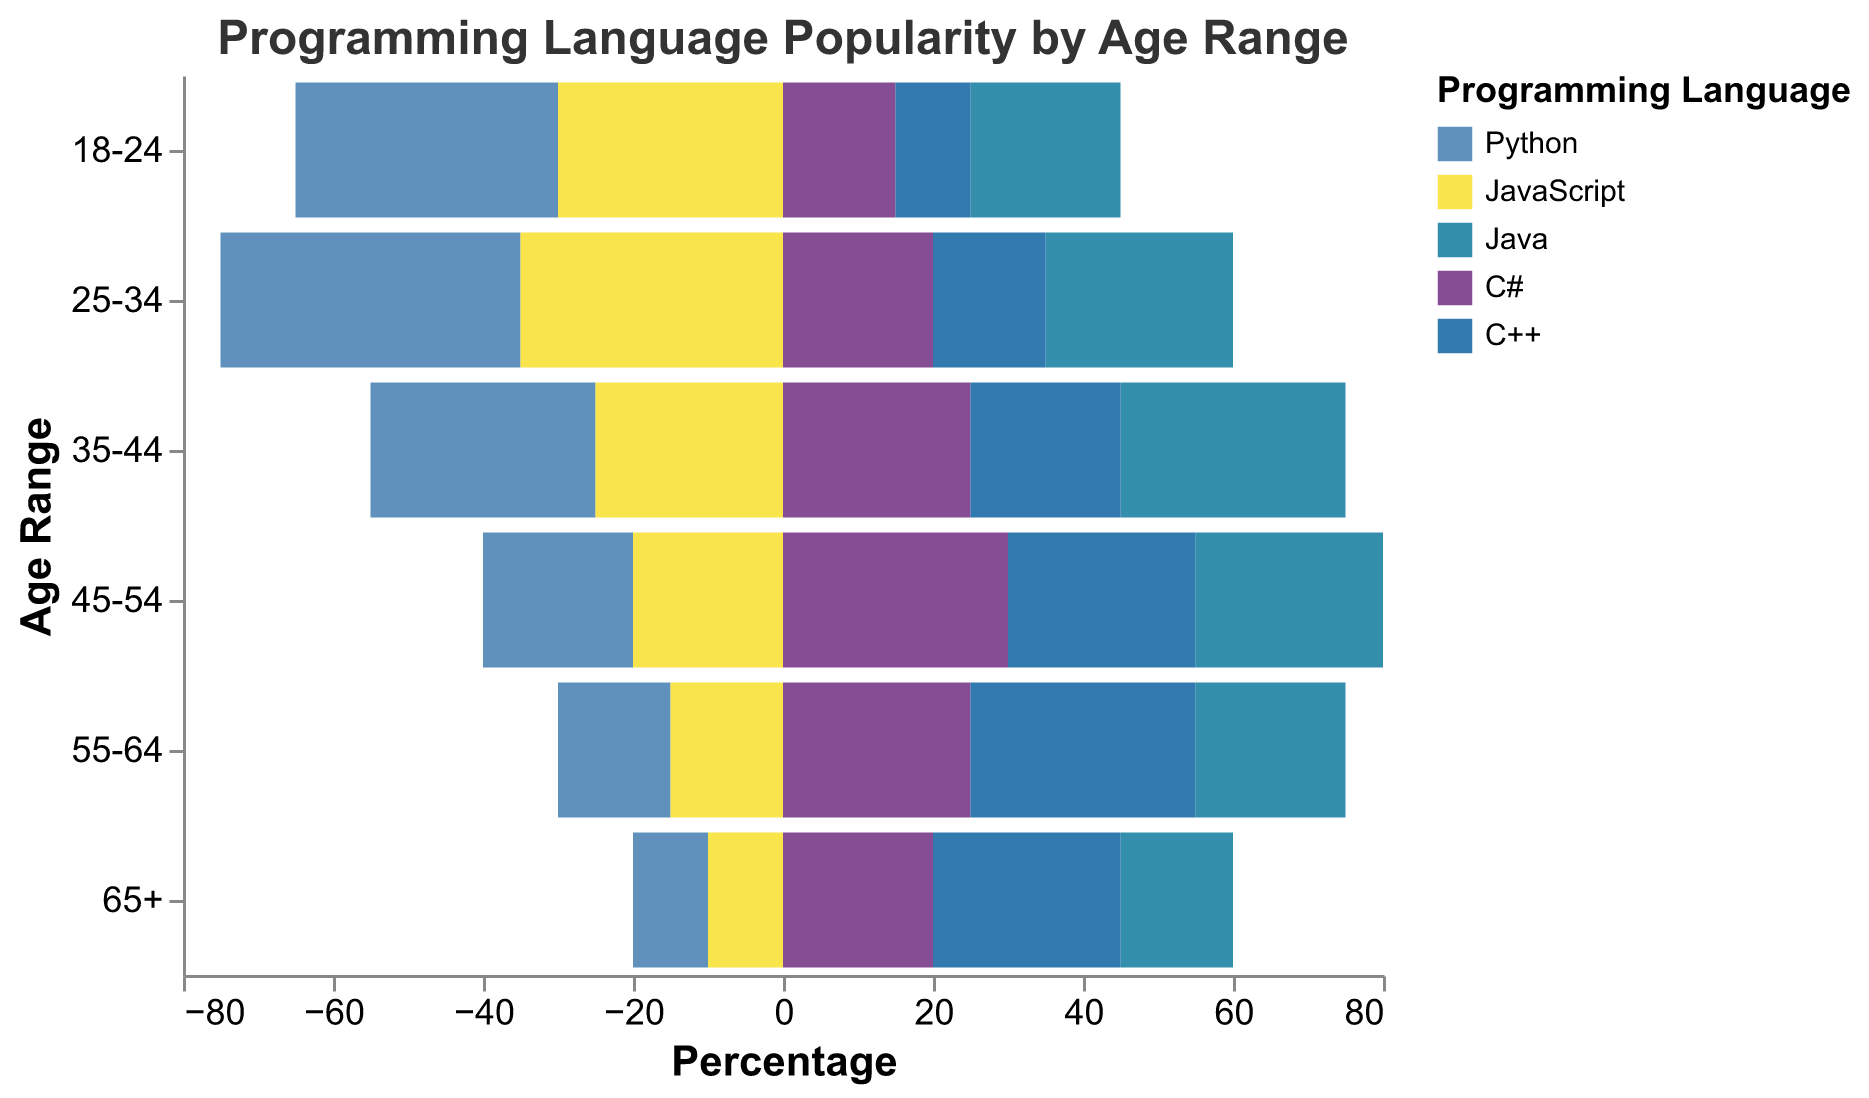What is the title of the figure? The title is positioned at the top of the figure and provides a summary of what the visual represents.
Answer: Programming Language Popularity by Age Range Which two languages have negative percentages in the data? By looking at the bars that extend to the left (negative direction) in the figure, we can identify the languages with negative percentages.
Answer: Python and JavaScript In the age range 25-34, which programming language is the most popular? For the age range 25-34, identify the language with the longest bar extending to the right.
Answer: Python How does the popularity of Python and JavaScript compare across all age ranges? Compare the lengths of bars for Python and JavaScript across each age range. Both languages have bars on the negative side, so observe which age ranges have longer bars for each language.
Answer: Python is generally more popular than JavaScript, but both decrease in popularity with age Which age range has the highest percentage of C# programmers? Identify the age range with the longest bar for C#. The C# bars are on the right side of the centerline.
Answer: 45-54 How many languages are visualized in the figure? Count the number of different colors representing distinct languages in the legend.
Answer: 5 What is the trend for C++ popularity as age increases? Look at the bars for C++ across all age ranges and observe whether the percentage increases or decreases with age.
Answer: It increases with age Compare the popularity of Java in the age groups 18-24 and 35-44. Which age group has higher popularity? Look at the bars for Java in the age groups 18-24 and 35-44 and compare their lengths.
Answer: 35-44 Which programming language shows a decrease in popularity in every subsequent age range? Look at each programming language and its bar lengths across increasing age ranges to identify any that continuously decrease.
Answer: Python For the age group 55-64, which language is equally popular to JavaScript? Find the age range 55-64 and compare the JavaScript bar with the other bars to see which language has the same length.
Answer: Python 